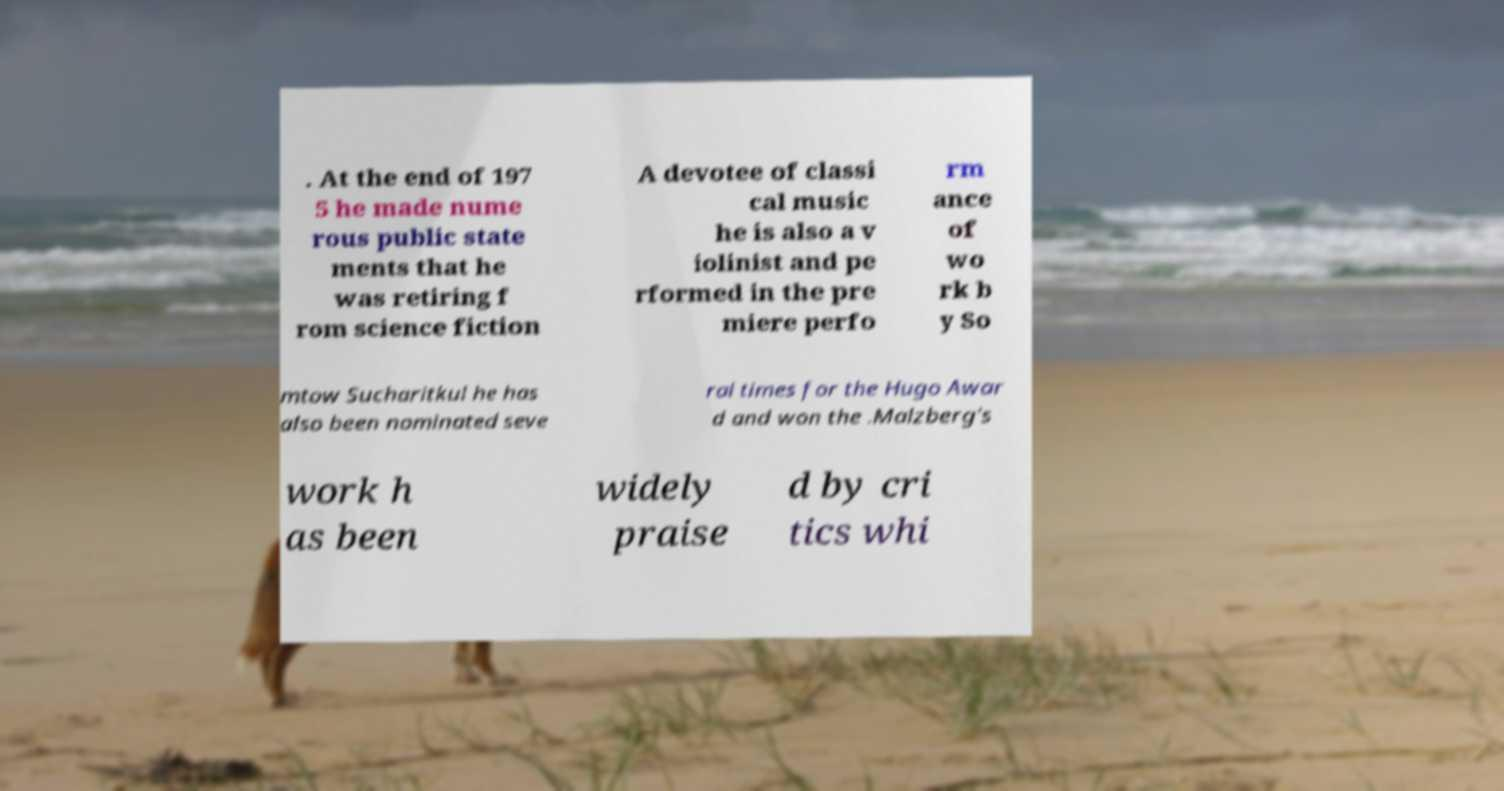Please identify and transcribe the text found in this image. . At the end of 197 5 he made nume rous public state ments that he was retiring f rom science fiction A devotee of classi cal music he is also a v iolinist and pe rformed in the pre miere perfo rm ance of wo rk b y So mtow Sucharitkul he has also been nominated seve ral times for the Hugo Awar d and won the .Malzberg's work h as been widely praise d by cri tics whi 